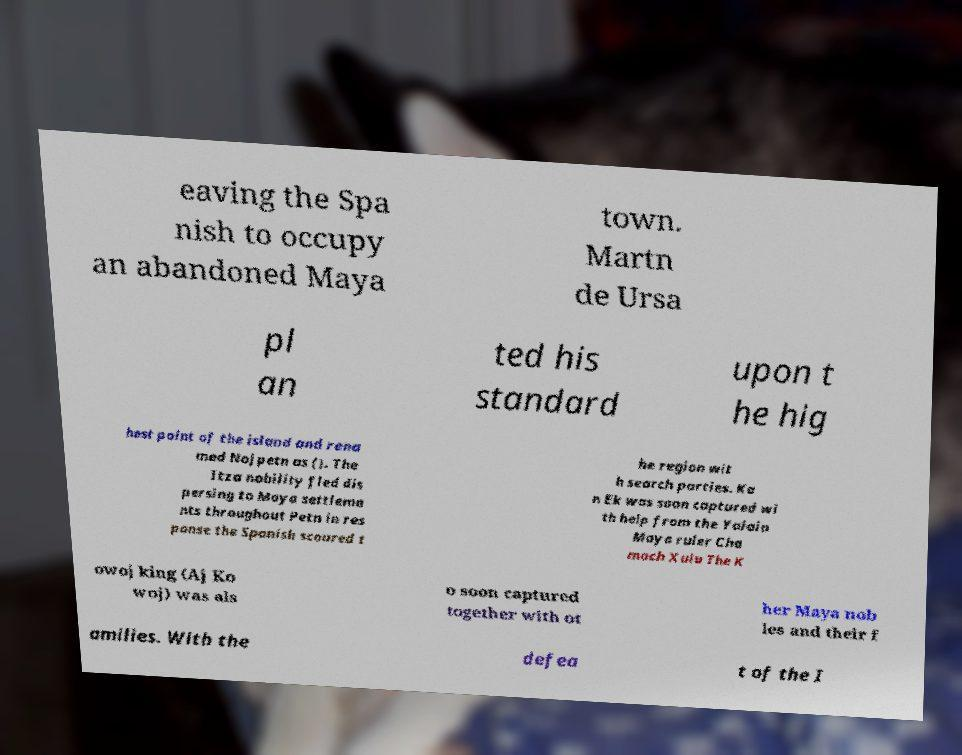Can you read and provide the text displayed in the image?This photo seems to have some interesting text. Can you extract and type it out for me? eaving the Spa nish to occupy an abandoned Maya town. Martn de Ursa pl an ted his standard upon t he hig hest point of the island and rena med Nojpetn as (). The Itza nobility fled dis persing to Maya settleme nts throughout Petn in res ponse the Spanish scoured t he region wit h search parties. Ka n Ek was soon captured wi th help from the Yalain Maya ruler Cha mach Xulu The K owoj king (Aj Ko woj) was als o soon captured together with ot her Maya nob les and their f amilies. With the defea t of the I 